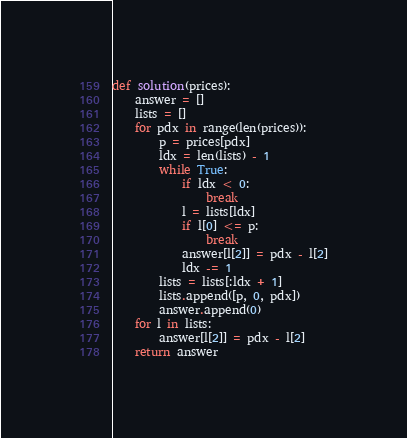<code> <loc_0><loc_0><loc_500><loc_500><_Python_>def solution(prices):
    answer = []
    lists = []
    for pdx in range(len(prices)):
        p = prices[pdx]
        ldx = len(lists) - 1
        while True:
            if ldx < 0:
                break
            l = lists[ldx]
            if l[0] <= p:
                break
            answer[l[2]] = pdx - l[2]
            ldx -= 1
        lists = lists[:ldx + 1]
        lists.append([p, 0, pdx])
        answer.append(0)
    for l in lists:
        answer[l[2]] = pdx - l[2]
    return answer
</code> 